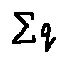<formula> <loc_0><loc_0><loc_500><loc_500>\sum q</formula> 